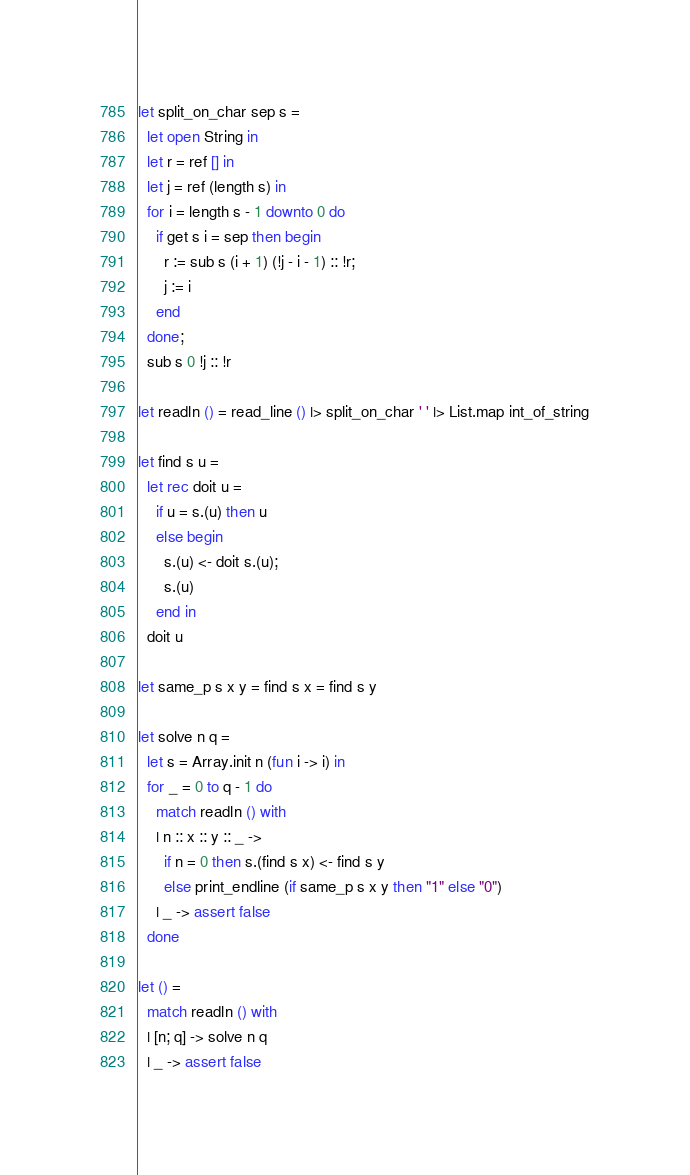<code> <loc_0><loc_0><loc_500><loc_500><_OCaml_>let split_on_char sep s =
  let open String in
  let r = ref [] in
  let j = ref (length s) in
  for i = length s - 1 downto 0 do
    if get s i = sep then begin
      r := sub s (i + 1) (!j - i - 1) :: !r;
      j := i
    end
  done;
  sub s 0 !j :: !r

let readln () = read_line () |> split_on_char ' ' |> List.map int_of_string

let find s u =
  let rec doit u =
    if u = s.(u) then u
    else begin
      s.(u) <- doit s.(u);
      s.(u)
    end in
  doit u

let same_p s x y = find s x = find s y

let solve n q =
  let s = Array.init n (fun i -> i) in
  for _ = 0 to q - 1 do
    match readln () with
    | n :: x :: y :: _ ->
      if n = 0 then s.(find s x) <- find s y
      else print_endline (if same_p s x y then "1" else "0")
    | _ -> assert false
  done

let () =
  match readln () with
  | [n; q] -> solve n q
  | _ -> assert false</code> 